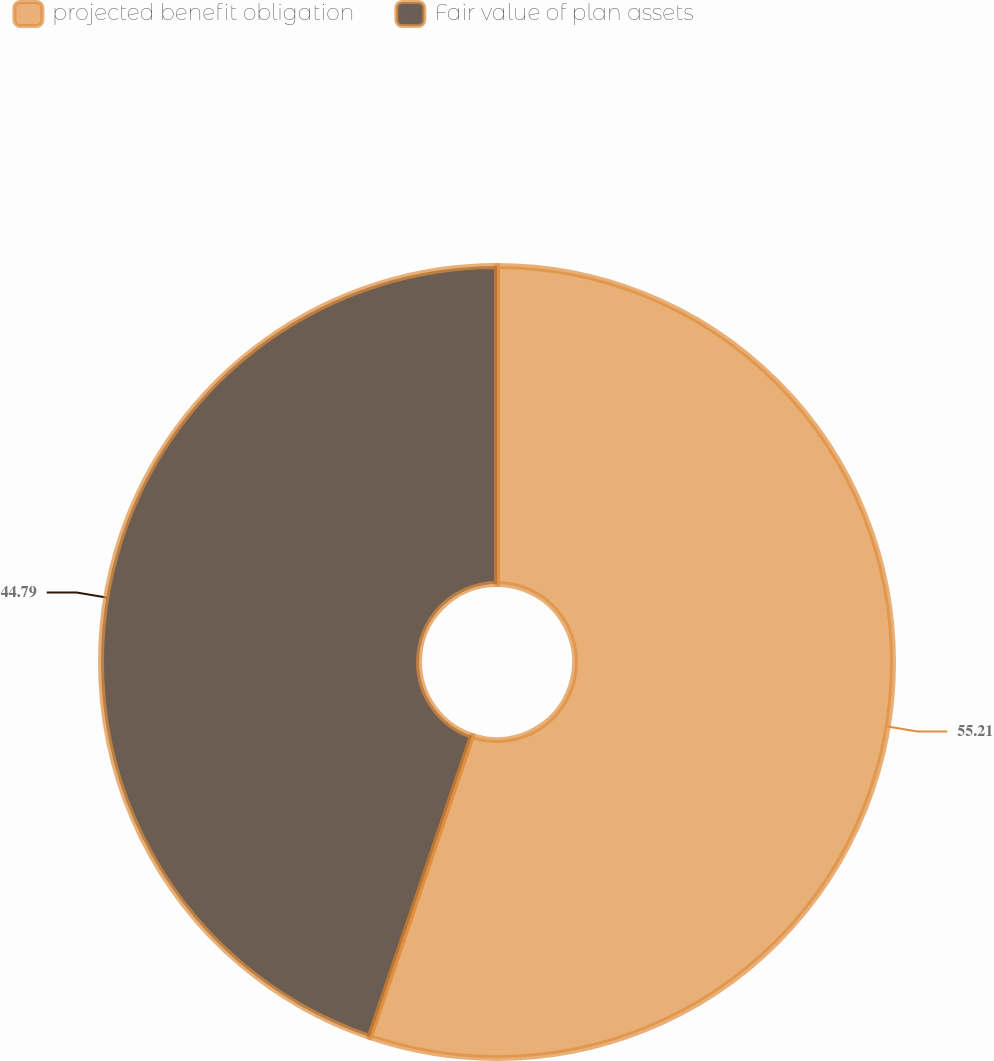<chart> <loc_0><loc_0><loc_500><loc_500><pie_chart><fcel>projected benefit obligation<fcel>Fair value of plan assets<nl><fcel>55.21%<fcel>44.79%<nl></chart> 